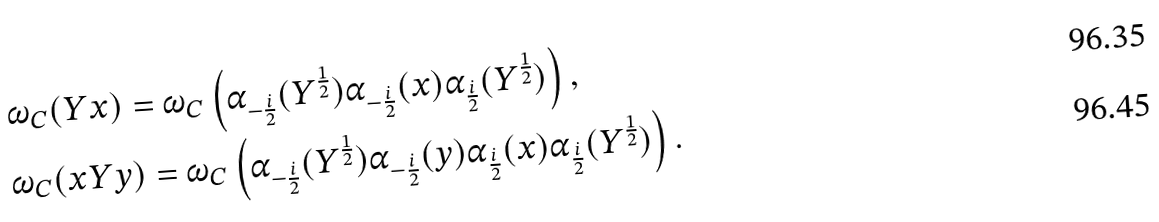Convert formula to latex. <formula><loc_0><loc_0><loc_500><loc_500>& \omega _ { C } ( Y x ) = \omega _ { C } \left ( \alpha _ { - \frac { i } { 2 } } ( Y ^ { \frac { 1 } { 2 } } ) \alpha _ { - \frac { i } { 2 } } ( x ) \alpha _ { \frac { i } { 2 } } ( Y ^ { \frac { 1 } { 2 } } ) \right ) , \\ & \omega _ { C } ( x Y y ) = \omega _ { C } \left ( \alpha _ { - \frac { i } { 2 } } ( Y ^ { \frac { 1 } { 2 } } ) \alpha _ { - \frac { i } { 2 } } ( y ) \alpha _ { \frac { i } { 2 } } ( x ) \alpha _ { \frac { i } { 2 } } ( Y ^ { \frac { 1 } { 2 } } ) \right ) .</formula> 